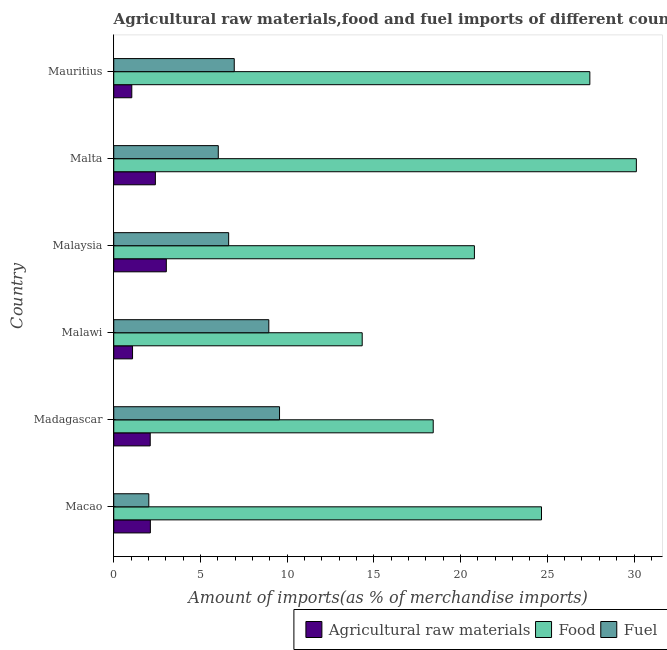How many groups of bars are there?
Provide a short and direct response. 6. Are the number of bars per tick equal to the number of legend labels?
Offer a very short reply. Yes. Are the number of bars on each tick of the Y-axis equal?
Ensure brevity in your answer.  Yes. What is the label of the 4th group of bars from the top?
Offer a very short reply. Malawi. What is the percentage of food imports in Malaysia?
Provide a succinct answer. 20.8. Across all countries, what is the maximum percentage of food imports?
Make the answer very short. 30.14. Across all countries, what is the minimum percentage of food imports?
Ensure brevity in your answer.  14.33. In which country was the percentage of fuel imports maximum?
Ensure brevity in your answer.  Madagascar. In which country was the percentage of fuel imports minimum?
Offer a very short reply. Macao. What is the total percentage of food imports in the graph?
Provide a short and direct response. 135.8. What is the difference between the percentage of raw materials imports in Madagascar and that in Mauritius?
Offer a terse response. 1.06. What is the difference between the percentage of raw materials imports in Malta and the percentage of fuel imports in Mauritius?
Make the answer very short. -4.55. What is the average percentage of raw materials imports per country?
Give a very brief answer. 1.96. What is the difference between the percentage of food imports and percentage of raw materials imports in Malta?
Your answer should be very brief. 27.74. What is the ratio of the percentage of food imports in Malta to that in Mauritius?
Your answer should be compact. 1.1. Is the percentage of fuel imports in Macao less than that in Malta?
Provide a short and direct response. Yes. Is the difference between the percentage of raw materials imports in Macao and Madagascar greater than the difference between the percentage of fuel imports in Macao and Madagascar?
Provide a short and direct response. Yes. What is the difference between the highest and the second highest percentage of food imports?
Your answer should be compact. 2.68. What is the difference between the highest and the lowest percentage of fuel imports?
Make the answer very short. 7.54. Is the sum of the percentage of food imports in Macao and Madagascar greater than the maximum percentage of raw materials imports across all countries?
Provide a short and direct response. Yes. What does the 2nd bar from the top in Mauritius represents?
Your answer should be very brief. Food. What does the 1st bar from the bottom in Madagascar represents?
Give a very brief answer. Agricultural raw materials. How many bars are there?
Offer a terse response. 18. How many countries are there in the graph?
Give a very brief answer. 6. What is the difference between two consecutive major ticks on the X-axis?
Your response must be concise. 5. Are the values on the major ticks of X-axis written in scientific E-notation?
Ensure brevity in your answer.  No. Does the graph contain any zero values?
Ensure brevity in your answer.  No. How many legend labels are there?
Your answer should be very brief. 3. How are the legend labels stacked?
Provide a short and direct response. Horizontal. What is the title of the graph?
Offer a terse response. Agricultural raw materials,food and fuel imports of different countries in 1973. What is the label or title of the X-axis?
Offer a very short reply. Amount of imports(as % of merchandise imports). What is the label or title of the Y-axis?
Offer a terse response. Country. What is the Amount of imports(as % of merchandise imports) in Agricultural raw materials in Macao?
Keep it short and to the point. 2.11. What is the Amount of imports(as % of merchandise imports) of Food in Macao?
Give a very brief answer. 24.67. What is the Amount of imports(as % of merchandise imports) of Fuel in Macao?
Provide a short and direct response. 2.02. What is the Amount of imports(as % of merchandise imports) of Agricultural raw materials in Madagascar?
Your answer should be compact. 2.1. What is the Amount of imports(as % of merchandise imports) of Food in Madagascar?
Provide a short and direct response. 18.42. What is the Amount of imports(as % of merchandise imports) in Fuel in Madagascar?
Keep it short and to the point. 9.56. What is the Amount of imports(as % of merchandise imports) in Agricultural raw materials in Malawi?
Your response must be concise. 1.08. What is the Amount of imports(as % of merchandise imports) of Food in Malawi?
Keep it short and to the point. 14.33. What is the Amount of imports(as % of merchandise imports) in Fuel in Malawi?
Ensure brevity in your answer.  8.94. What is the Amount of imports(as % of merchandise imports) in Agricultural raw materials in Malaysia?
Keep it short and to the point. 3.03. What is the Amount of imports(as % of merchandise imports) of Food in Malaysia?
Your answer should be very brief. 20.8. What is the Amount of imports(as % of merchandise imports) in Fuel in Malaysia?
Provide a succinct answer. 6.63. What is the Amount of imports(as % of merchandise imports) in Agricultural raw materials in Malta?
Your answer should be compact. 2.4. What is the Amount of imports(as % of merchandise imports) of Food in Malta?
Your answer should be compact. 30.14. What is the Amount of imports(as % of merchandise imports) of Fuel in Malta?
Your answer should be compact. 6.03. What is the Amount of imports(as % of merchandise imports) in Agricultural raw materials in Mauritius?
Make the answer very short. 1.04. What is the Amount of imports(as % of merchandise imports) of Food in Mauritius?
Offer a terse response. 27.45. What is the Amount of imports(as % of merchandise imports) in Fuel in Mauritius?
Keep it short and to the point. 6.95. Across all countries, what is the maximum Amount of imports(as % of merchandise imports) of Agricultural raw materials?
Offer a very short reply. 3.03. Across all countries, what is the maximum Amount of imports(as % of merchandise imports) in Food?
Provide a succinct answer. 30.14. Across all countries, what is the maximum Amount of imports(as % of merchandise imports) of Fuel?
Offer a very short reply. 9.56. Across all countries, what is the minimum Amount of imports(as % of merchandise imports) in Agricultural raw materials?
Provide a short and direct response. 1.04. Across all countries, what is the minimum Amount of imports(as % of merchandise imports) of Food?
Offer a very short reply. 14.33. Across all countries, what is the minimum Amount of imports(as % of merchandise imports) of Fuel?
Your answer should be very brief. 2.02. What is the total Amount of imports(as % of merchandise imports) of Agricultural raw materials in the graph?
Provide a short and direct response. 11.77. What is the total Amount of imports(as % of merchandise imports) in Food in the graph?
Offer a terse response. 135.8. What is the total Amount of imports(as % of merchandise imports) in Fuel in the graph?
Make the answer very short. 40.13. What is the difference between the Amount of imports(as % of merchandise imports) in Agricultural raw materials in Macao and that in Madagascar?
Offer a very short reply. 0.01. What is the difference between the Amount of imports(as % of merchandise imports) of Food in Macao and that in Madagascar?
Offer a very short reply. 6.24. What is the difference between the Amount of imports(as % of merchandise imports) in Fuel in Macao and that in Madagascar?
Make the answer very short. -7.54. What is the difference between the Amount of imports(as % of merchandise imports) in Agricultural raw materials in Macao and that in Malawi?
Ensure brevity in your answer.  1.03. What is the difference between the Amount of imports(as % of merchandise imports) of Food in Macao and that in Malawi?
Provide a succinct answer. 10.34. What is the difference between the Amount of imports(as % of merchandise imports) of Fuel in Macao and that in Malawi?
Offer a very short reply. -6.92. What is the difference between the Amount of imports(as % of merchandise imports) in Agricultural raw materials in Macao and that in Malaysia?
Provide a short and direct response. -0.92. What is the difference between the Amount of imports(as % of merchandise imports) in Food in Macao and that in Malaysia?
Your answer should be very brief. 3.87. What is the difference between the Amount of imports(as % of merchandise imports) in Fuel in Macao and that in Malaysia?
Offer a very short reply. -4.6. What is the difference between the Amount of imports(as % of merchandise imports) in Agricultural raw materials in Macao and that in Malta?
Provide a succinct answer. -0.29. What is the difference between the Amount of imports(as % of merchandise imports) in Food in Macao and that in Malta?
Keep it short and to the point. -5.47. What is the difference between the Amount of imports(as % of merchandise imports) of Fuel in Macao and that in Malta?
Provide a succinct answer. -4.01. What is the difference between the Amount of imports(as % of merchandise imports) of Agricultural raw materials in Macao and that in Mauritius?
Keep it short and to the point. 1.07. What is the difference between the Amount of imports(as % of merchandise imports) of Food in Macao and that in Mauritius?
Provide a succinct answer. -2.79. What is the difference between the Amount of imports(as % of merchandise imports) of Fuel in Macao and that in Mauritius?
Your response must be concise. -4.93. What is the difference between the Amount of imports(as % of merchandise imports) of Agricultural raw materials in Madagascar and that in Malawi?
Keep it short and to the point. 1.02. What is the difference between the Amount of imports(as % of merchandise imports) in Food in Madagascar and that in Malawi?
Your answer should be very brief. 4.09. What is the difference between the Amount of imports(as % of merchandise imports) in Fuel in Madagascar and that in Malawi?
Give a very brief answer. 0.62. What is the difference between the Amount of imports(as % of merchandise imports) of Agricultural raw materials in Madagascar and that in Malaysia?
Make the answer very short. -0.93. What is the difference between the Amount of imports(as % of merchandise imports) in Food in Madagascar and that in Malaysia?
Provide a short and direct response. -2.38. What is the difference between the Amount of imports(as % of merchandise imports) in Fuel in Madagascar and that in Malaysia?
Your answer should be compact. 2.93. What is the difference between the Amount of imports(as % of merchandise imports) of Agricultural raw materials in Madagascar and that in Malta?
Ensure brevity in your answer.  -0.3. What is the difference between the Amount of imports(as % of merchandise imports) in Food in Madagascar and that in Malta?
Give a very brief answer. -11.71. What is the difference between the Amount of imports(as % of merchandise imports) in Fuel in Madagascar and that in Malta?
Keep it short and to the point. 3.53. What is the difference between the Amount of imports(as % of merchandise imports) of Food in Madagascar and that in Mauritius?
Offer a very short reply. -9.03. What is the difference between the Amount of imports(as % of merchandise imports) in Fuel in Madagascar and that in Mauritius?
Make the answer very short. 2.61. What is the difference between the Amount of imports(as % of merchandise imports) in Agricultural raw materials in Malawi and that in Malaysia?
Ensure brevity in your answer.  -1.95. What is the difference between the Amount of imports(as % of merchandise imports) in Food in Malawi and that in Malaysia?
Give a very brief answer. -6.47. What is the difference between the Amount of imports(as % of merchandise imports) in Fuel in Malawi and that in Malaysia?
Offer a very short reply. 2.32. What is the difference between the Amount of imports(as % of merchandise imports) of Agricultural raw materials in Malawi and that in Malta?
Make the answer very short. -1.32. What is the difference between the Amount of imports(as % of merchandise imports) of Food in Malawi and that in Malta?
Your response must be concise. -15.81. What is the difference between the Amount of imports(as % of merchandise imports) in Fuel in Malawi and that in Malta?
Provide a short and direct response. 2.91. What is the difference between the Amount of imports(as % of merchandise imports) in Agricultural raw materials in Malawi and that in Mauritius?
Your answer should be very brief. 0.04. What is the difference between the Amount of imports(as % of merchandise imports) in Food in Malawi and that in Mauritius?
Offer a very short reply. -13.13. What is the difference between the Amount of imports(as % of merchandise imports) of Fuel in Malawi and that in Mauritius?
Your response must be concise. 1.99. What is the difference between the Amount of imports(as % of merchandise imports) of Agricultural raw materials in Malaysia and that in Malta?
Provide a short and direct response. 0.63. What is the difference between the Amount of imports(as % of merchandise imports) of Food in Malaysia and that in Malta?
Provide a short and direct response. -9.34. What is the difference between the Amount of imports(as % of merchandise imports) in Fuel in Malaysia and that in Malta?
Keep it short and to the point. 0.6. What is the difference between the Amount of imports(as % of merchandise imports) in Agricultural raw materials in Malaysia and that in Mauritius?
Offer a terse response. 1.99. What is the difference between the Amount of imports(as % of merchandise imports) in Food in Malaysia and that in Mauritius?
Ensure brevity in your answer.  -6.66. What is the difference between the Amount of imports(as % of merchandise imports) in Fuel in Malaysia and that in Mauritius?
Offer a very short reply. -0.32. What is the difference between the Amount of imports(as % of merchandise imports) in Agricultural raw materials in Malta and that in Mauritius?
Give a very brief answer. 1.36. What is the difference between the Amount of imports(as % of merchandise imports) in Food in Malta and that in Mauritius?
Keep it short and to the point. 2.68. What is the difference between the Amount of imports(as % of merchandise imports) of Fuel in Malta and that in Mauritius?
Offer a terse response. -0.92. What is the difference between the Amount of imports(as % of merchandise imports) of Agricultural raw materials in Macao and the Amount of imports(as % of merchandise imports) of Food in Madagascar?
Your answer should be compact. -16.31. What is the difference between the Amount of imports(as % of merchandise imports) in Agricultural raw materials in Macao and the Amount of imports(as % of merchandise imports) in Fuel in Madagascar?
Make the answer very short. -7.45. What is the difference between the Amount of imports(as % of merchandise imports) in Food in Macao and the Amount of imports(as % of merchandise imports) in Fuel in Madagascar?
Provide a succinct answer. 15.11. What is the difference between the Amount of imports(as % of merchandise imports) of Agricultural raw materials in Macao and the Amount of imports(as % of merchandise imports) of Food in Malawi?
Offer a terse response. -12.22. What is the difference between the Amount of imports(as % of merchandise imports) in Agricultural raw materials in Macao and the Amount of imports(as % of merchandise imports) in Fuel in Malawi?
Provide a short and direct response. -6.83. What is the difference between the Amount of imports(as % of merchandise imports) in Food in Macao and the Amount of imports(as % of merchandise imports) in Fuel in Malawi?
Make the answer very short. 15.72. What is the difference between the Amount of imports(as % of merchandise imports) in Agricultural raw materials in Macao and the Amount of imports(as % of merchandise imports) in Food in Malaysia?
Provide a short and direct response. -18.69. What is the difference between the Amount of imports(as % of merchandise imports) in Agricultural raw materials in Macao and the Amount of imports(as % of merchandise imports) in Fuel in Malaysia?
Make the answer very short. -4.52. What is the difference between the Amount of imports(as % of merchandise imports) of Food in Macao and the Amount of imports(as % of merchandise imports) of Fuel in Malaysia?
Ensure brevity in your answer.  18.04. What is the difference between the Amount of imports(as % of merchandise imports) in Agricultural raw materials in Macao and the Amount of imports(as % of merchandise imports) in Food in Malta?
Provide a short and direct response. -28.02. What is the difference between the Amount of imports(as % of merchandise imports) in Agricultural raw materials in Macao and the Amount of imports(as % of merchandise imports) in Fuel in Malta?
Your answer should be compact. -3.92. What is the difference between the Amount of imports(as % of merchandise imports) of Food in Macao and the Amount of imports(as % of merchandise imports) of Fuel in Malta?
Offer a terse response. 18.64. What is the difference between the Amount of imports(as % of merchandise imports) of Agricultural raw materials in Macao and the Amount of imports(as % of merchandise imports) of Food in Mauritius?
Offer a terse response. -25.34. What is the difference between the Amount of imports(as % of merchandise imports) of Agricultural raw materials in Macao and the Amount of imports(as % of merchandise imports) of Fuel in Mauritius?
Your response must be concise. -4.84. What is the difference between the Amount of imports(as % of merchandise imports) of Food in Macao and the Amount of imports(as % of merchandise imports) of Fuel in Mauritius?
Give a very brief answer. 17.72. What is the difference between the Amount of imports(as % of merchandise imports) in Agricultural raw materials in Madagascar and the Amount of imports(as % of merchandise imports) in Food in Malawi?
Provide a short and direct response. -12.22. What is the difference between the Amount of imports(as % of merchandise imports) of Agricultural raw materials in Madagascar and the Amount of imports(as % of merchandise imports) of Fuel in Malawi?
Your answer should be very brief. -6.84. What is the difference between the Amount of imports(as % of merchandise imports) of Food in Madagascar and the Amount of imports(as % of merchandise imports) of Fuel in Malawi?
Make the answer very short. 9.48. What is the difference between the Amount of imports(as % of merchandise imports) of Agricultural raw materials in Madagascar and the Amount of imports(as % of merchandise imports) of Food in Malaysia?
Make the answer very short. -18.69. What is the difference between the Amount of imports(as % of merchandise imports) of Agricultural raw materials in Madagascar and the Amount of imports(as % of merchandise imports) of Fuel in Malaysia?
Provide a short and direct response. -4.52. What is the difference between the Amount of imports(as % of merchandise imports) in Food in Madagascar and the Amount of imports(as % of merchandise imports) in Fuel in Malaysia?
Provide a succinct answer. 11.8. What is the difference between the Amount of imports(as % of merchandise imports) of Agricultural raw materials in Madagascar and the Amount of imports(as % of merchandise imports) of Food in Malta?
Your response must be concise. -28.03. What is the difference between the Amount of imports(as % of merchandise imports) of Agricultural raw materials in Madagascar and the Amount of imports(as % of merchandise imports) of Fuel in Malta?
Your response must be concise. -3.92. What is the difference between the Amount of imports(as % of merchandise imports) in Food in Madagascar and the Amount of imports(as % of merchandise imports) in Fuel in Malta?
Provide a succinct answer. 12.39. What is the difference between the Amount of imports(as % of merchandise imports) of Agricultural raw materials in Madagascar and the Amount of imports(as % of merchandise imports) of Food in Mauritius?
Provide a succinct answer. -25.35. What is the difference between the Amount of imports(as % of merchandise imports) in Agricultural raw materials in Madagascar and the Amount of imports(as % of merchandise imports) in Fuel in Mauritius?
Your answer should be very brief. -4.84. What is the difference between the Amount of imports(as % of merchandise imports) of Food in Madagascar and the Amount of imports(as % of merchandise imports) of Fuel in Mauritius?
Offer a terse response. 11.47. What is the difference between the Amount of imports(as % of merchandise imports) in Agricultural raw materials in Malawi and the Amount of imports(as % of merchandise imports) in Food in Malaysia?
Your answer should be very brief. -19.71. What is the difference between the Amount of imports(as % of merchandise imports) in Agricultural raw materials in Malawi and the Amount of imports(as % of merchandise imports) in Fuel in Malaysia?
Provide a short and direct response. -5.54. What is the difference between the Amount of imports(as % of merchandise imports) of Food in Malawi and the Amount of imports(as % of merchandise imports) of Fuel in Malaysia?
Your answer should be compact. 7.7. What is the difference between the Amount of imports(as % of merchandise imports) of Agricultural raw materials in Malawi and the Amount of imports(as % of merchandise imports) of Food in Malta?
Keep it short and to the point. -29.05. What is the difference between the Amount of imports(as % of merchandise imports) in Agricultural raw materials in Malawi and the Amount of imports(as % of merchandise imports) in Fuel in Malta?
Ensure brevity in your answer.  -4.94. What is the difference between the Amount of imports(as % of merchandise imports) in Food in Malawi and the Amount of imports(as % of merchandise imports) in Fuel in Malta?
Your response must be concise. 8.3. What is the difference between the Amount of imports(as % of merchandise imports) in Agricultural raw materials in Malawi and the Amount of imports(as % of merchandise imports) in Food in Mauritius?
Provide a succinct answer. -26.37. What is the difference between the Amount of imports(as % of merchandise imports) in Agricultural raw materials in Malawi and the Amount of imports(as % of merchandise imports) in Fuel in Mauritius?
Give a very brief answer. -5.86. What is the difference between the Amount of imports(as % of merchandise imports) in Food in Malawi and the Amount of imports(as % of merchandise imports) in Fuel in Mauritius?
Provide a succinct answer. 7.38. What is the difference between the Amount of imports(as % of merchandise imports) in Agricultural raw materials in Malaysia and the Amount of imports(as % of merchandise imports) in Food in Malta?
Give a very brief answer. -27.1. What is the difference between the Amount of imports(as % of merchandise imports) in Agricultural raw materials in Malaysia and the Amount of imports(as % of merchandise imports) in Fuel in Malta?
Your answer should be very brief. -3. What is the difference between the Amount of imports(as % of merchandise imports) in Food in Malaysia and the Amount of imports(as % of merchandise imports) in Fuel in Malta?
Offer a terse response. 14.77. What is the difference between the Amount of imports(as % of merchandise imports) of Agricultural raw materials in Malaysia and the Amount of imports(as % of merchandise imports) of Food in Mauritius?
Ensure brevity in your answer.  -24.42. What is the difference between the Amount of imports(as % of merchandise imports) of Agricultural raw materials in Malaysia and the Amount of imports(as % of merchandise imports) of Fuel in Mauritius?
Make the answer very short. -3.92. What is the difference between the Amount of imports(as % of merchandise imports) in Food in Malaysia and the Amount of imports(as % of merchandise imports) in Fuel in Mauritius?
Offer a terse response. 13.85. What is the difference between the Amount of imports(as % of merchandise imports) of Agricultural raw materials in Malta and the Amount of imports(as % of merchandise imports) of Food in Mauritius?
Offer a very short reply. -25.05. What is the difference between the Amount of imports(as % of merchandise imports) in Agricultural raw materials in Malta and the Amount of imports(as % of merchandise imports) in Fuel in Mauritius?
Ensure brevity in your answer.  -4.55. What is the difference between the Amount of imports(as % of merchandise imports) of Food in Malta and the Amount of imports(as % of merchandise imports) of Fuel in Mauritius?
Your response must be concise. 23.19. What is the average Amount of imports(as % of merchandise imports) in Agricultural raw materials per country?
Your response must be concise. 1.96. What is the average Amount of imports(as % of merchandise imports) of Food per country?
Your answer should be very brief. 22.63. What is the average Amount of imports(as % of merchandise imports) of Fuel per country?
Make the answer very short. 6.69. What is the difference between the Amount of imports(as % of merchandise imports) in Agricultural raw materials and Amount of imports(as % of merchandise imports) in Food in Macao?
Your answer should be very brief. -22.55. What is the difference between the Amount of imports(as % of merchandise imports) of Agricultural raw materials and Amount of imports(as % of merchandise imports) of Fuel in Macao?
Your answer should be very brief. 0.09. What is the difference between the Amount of imports(as % of merchandise imports) in Food and Amount of imports(as % of merchandise imports) in Fuel in Macao?
Your answer should be compact. 22.64. What is the difference between the Amount of imports(as % of merchandise imports) in Agricultural raw materials and Amount of imports(as % of merchandise imports) in Food in Madagascar?
Your response must be concise. -16.32. What is the difference between the Amount of imports(as % of merchandise imports) of Agricultural raw materials and Amount of imports(as % of merchandise imports) of Fuel in Madagascar?
Your answer should be very brief. -7.46. What is the difference between the Amount of imports(as % of merchandise imports) in Food and Amount of imports(as % of merchandise imports) in Fuel in Madagascar?
Offer a very short reply. 8.86. What is the difference between the Amount of imports(as % of merchandise imports) of Agricultural raw materials and Amount of imports(as % of merchandise imports) of Food in Malawi?
Your response must be concise. -13.24. What is the difference between the Amount of imports(as % of merchandise imports) in Agricultural raw materials and Amount of imports(as % of merchandise imports) in Fuel in Malawi?
Offer a very short reply. -7.86. What is the difference between the Amount of imports(as % of merchandise imports) in Food and Amount of imports(as % of merchandise imports) in Fuel in Malawi?
Offer a terse response. 5.39. What is the difference between the Amount of imports(as % of merchandise imports) in Agricultural raw materials and Amount of imports(as % of merchandise imports) in Food in Malaysia?
Keep it short and to the point. -17.77. What is the difference between the Amount of imports(as % of merchandise imports) in Agricultural raw materials and Amount of imports(as % of merchandise imports) in Fuel in Malaysia?
Your answer should be compact. -3.59. What is the difference between the Amount of imports(as % of merchandise imports) of Food and Amount of imports(as % of merchandise imports) of Fuel in Malaysia?
Offer a very short reply. 14.17. What is the difference between the Amount of imports(as % of merchandise imports) in Agricultural raw materials and Amount of imports(as % of merchandise imports) in Food in Malta?
Keep it short and to the point. -27.74. What is the difference between the Amount of imports(as % of merchandise imports) of Agricultural raw materials and Amount of imports(as % of merchandise imports) of Fuel in Malta?
Offer a very short reply. -3.63. What is the difference between the Amount of imports(as % of merchandise imports) in Food and Amount of imports(as % of merchandise imports) in Fuel in Malta?
Keep it short and to the point. 24.11. What is the difference between the Amount of imports(as % of merchandise imports) of Agricultural raw materials and Amount of imports(as % of merchandise imports) of Food in Mauritius?
Provide a short and direct response. -26.41. What is the difference between the Amount of imports(as % of merchandise imports) of Agricultural raw materials and Amount of imports(as % of merchandise imports) of Fuel in Mauritius?
Your answer should be compact. -5.91. What is the difference between the Amount of imports(as % of merchandise imports) of Food and Amount of imports(as % of merchandise imports) of Fuel in Mauritius?
Offer a very short reply. 20.5. What is the ratio of the Amount of imports(as % of merchandise imports) in Food in Macao to that in Madagascar?
Provide a succinct answer. 1.34. What is the ratio of the Amount of imports(as % of merchandise imports) in Fuel in Macao to that in Madagascar?
Keep it short and to the point. 0.21. What is the ratio of the Amount of imports(as % of merchandise imports) in Agricultural raw materials in Macao to that in Malawi?
Keep it short and to the point. 1.95. What is the ratio of the Amount of imports(as % of merchandise imports) of Food in Macao to that in Malawi?
Your answer should be compact. 1.72. What is the ratio of the Amount of imports(as % of merchandise imports) of Fuel in Macao to that in Malawi?
Keep it short and to the point. 0.23. What is the ratio of the Amount of imports(as % of merchandise imports) in Agricultural raw materials in Macao to that in Malaysia?
Provide a short and direct response. 0.7. What is the ratio of the Amount of imports(as % of merchandise imports) in Food in Macao to that in Malaysia?
Make the answer very short. 1.19. What is the ratio of the Amount of imports(as % of merchandise imports) in Fuel in Macao to that in Malaysia?
Your response must be concise. 0.31. What is the ratio of the Amount of imports(as % of merchandise imports) of Agricultural raw materials in Macao to that in Malta?
Your answer should be compact. 0.88. What is the ratio of the Amount of imports(as % of merchandise imports) in Food in Macao to that in Malta?
Make the answer very short. 0.82. What is the ratio of the Amount of imports(as % of merchandise imports) in Fuel in Macao to that in Malta?
Your answer should be very brief. 0.34. What is the ratio of the Amount of imports(as % of merchandise imports) of Agricultural raw materials in Macao to that in Mauritius?
Your answer should be very brief. 2.03. What is the ratio of the Amount of imports(as % of merchandise imports) in Food in Macao to that in Mauritius?
Your answer should be compact. 0.9. What is the ratio of the Amount of imports(as % of merchandise imports) in Fuel in Macao to that in Mauritius?
Provide a short and direct response. 0.29. What is the ratio of the Amount of imports(as % of merchandise imports) of Agricultural raw materials in Madagascar to that in Malawi?
Keep it short and to the point. 1.94. What is the ratio of the Amount of imports(as % of merchandise imports) of Food in Madagascar to that in Malawi?
Your response must be concise. 1.29. What is the ratio of the Amount of imports(as % of merchandise imports) in Fuel in Madagascar to that in Malawi?
Provide a short and direct response. 1.07. What is the ratio of the Amount of imports(as % of merchandise imports) in Agricultural raw materials in Madagascar to that in Malaysia?
Offer a very short reply. 0.69. What is the ratio of the Amount of imports(as % of merchandise imports) of Food in Madagascar to that in Malaysia?
Offer a very short reply. 0.89. What is the ratio of the Amount of imports(as % of merchandise imports) of Fuel in Madagascar to that in Malaysia?
Make the answer very short. 1.44. What is the ratio of the Amount of imports(as % of merchandise imports) of Agricultural raw materials in Madagascar to that in Malta?
Offer a terse response. 0.88. What is the ratio of the Amount of imports(as % of merchandise imports) of Food in Madagascar to that in Malta?
Give a very brief answer. 0.61. What is the ratio of the Amount of imports(as % of merchandise imports) in Fuel in Madagascar to that in Malta?
Provide a succinct answer. 1.59. What is the ratio of the Amount of imports(as % of merchandise imports) of Agricultural raw materials in Madagascar to that in Mauritius?
Offer a very short reply. 2.02. What is the ratio of the Amount of imports(as % of merchandise imports) in Food in Madagascar to that in Mauritius?
Your answer should be compact. 0.67. What is the ratio of the Amount of imports(as % of merchandise imports) of Fuel in Madagascar to that in Mauritius?
Offer a terse response. 1.38. What is the ratio of the Amount of imports(as % of merchandise imports) in Agricultural raw materials in Malawi to that in Malaysia?
Ensure brevity in your answer.  0.36. What is the ratio of the Amount of imports(as % of merchandise imports) of Food in Malawi to that in Malaysia?
Your response must be concise. 0.69. What is the ratio of the Amount of imports(as % of merchandise imports) in Fuel in Malawi to that in Malaysia?
Keep it short and to the point. 1.35. What is the ratio of the Amount of imports(as % of merchandise imports) in Agricultural raw materials in Malawi to that in Malta?
Make the answer very short. 0.45. What is the ratio of the Amount of imports(as % of merchandise imports) of Food in Malawi to that in Malta?
Give a very brief answer. 0.48. What is the ratio of the Amount of imports(as % of merchandise imports) of Fuel in Malawi to that in Malta?
Offer a terse response. 1.48. What is the ratio of the Amount of imports(as % of merchandise imports) in Agricultural raw materials in Malawi to that in Mauritius?
Your answer should be compact. 1.04. What is the ratio of the Amount of imports(as % of merchandise imports) in Food in Malawi to that in Mauritius?
Your response must be concise. 0.52. What is the ratio of the Amount of imports(as % of merchandise imports) in Fuel in Malawi to that in Mauritius?
Keep it short and to the point. 1.29. What is the ratio of the Amount of imports(as % of merchandise imports) in Agricultural raw materials in Malaysia to that in Malta?
Give a very brief answer. 1.26. What is the ratio of the Amount of imports(as % of merchandise imports) of Food in Malaysia to that in Malta?
Provide a succinct answer. 0.69. What is the ratio of the Amount of imports(as % of merchandise imports) in Fuel in Malaysia to that in Malta?
Offer a terse response. 1.1. What is the ratio of the Amount of imports(as % of merchandise imports) of Agricultural raw materials in Malaysia to that in Mauritius?
Your answer should be very brief. 2.91. What is the ratio of the Amount of imports(as % of merchandise imports) of Food in Malaysia to that in Mauritius?
Keep it short and to the point. 0.76. What is the ratio of the Amount of imports(as % of merchandise imports) in Fuel in Malaysia to that in Mauritius?
Keep it short and to the point. 0.95. What is the ratio of the Amount of imports(as % of merchandise imports) of Agricultural raw materials in Malta to that in Mauritius?
Keep it short and to the point. 2.31. What is the ratio of the Amount of imports(as % of merchandise imports) of Food in Malta to that in Mauritius?
Offer a very short reply. 1.1. What is the ratio of the Amount of imports(as % of merchandise imports) of Fuel in Malta to that in Mauritius?
Make the answer very short. 0.87. What is the difference between the highest and the second highest Amount of imports(as % of merchandise imports) in Agricultural raw materials?
Offer a terse response. 0.63. What is the difference between the highest and the second highest Amount of imports(as % of merchandise imports) in Food?
Your answer should be very brief. 2.68. What is the difference between the highest and the second highest Amount of imports(as % of merchandise imports) of Fuel?
Keep it short and to the point. 0.62. What is the difference between the highest and the lowest Amount of imports(as % of merchandise imports) of Agricultural raw materials?
Give a very brief answer. 1.99. What is the difference between the highest and the lowest Amount of imports(as % of merchandise imports) of Food?
Ensure brevity in your answer.  15.81. What is the difference between the highest and the lowest Amount of imports(as % of merchandise imports) in Fuel?
Your response must be concise. 7.54. 